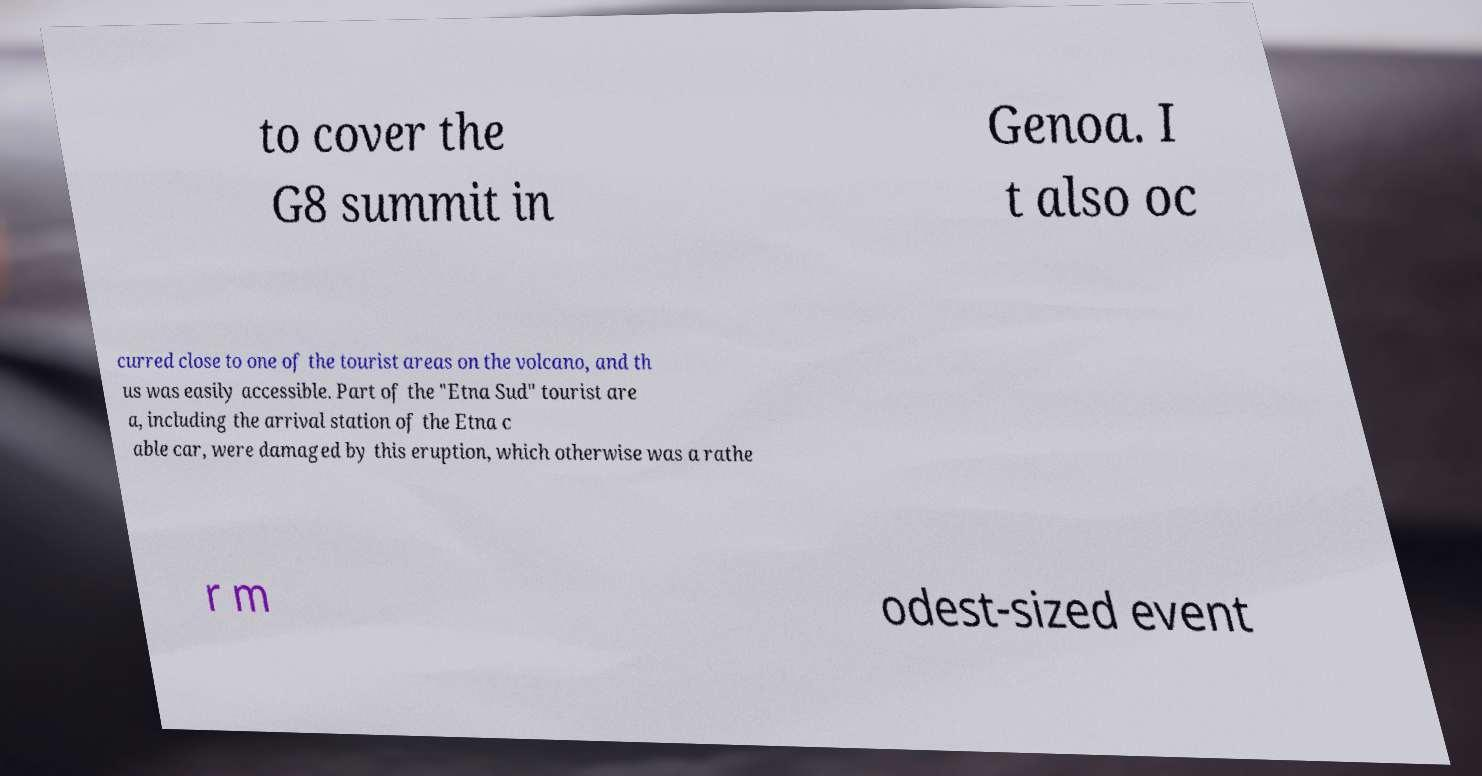Please read and relay the text visible in this image. What does it say? to cover the G8 summit in Genoa. I t also oc curred close to one of the tourist areas on the volcano, and th us was easily accessible. Part of the "Etna Sud" tourist are a, including the arrival station of the Etna c able car, were damaged by this eruption, which otherwise was a rathe r m odest-sized event 